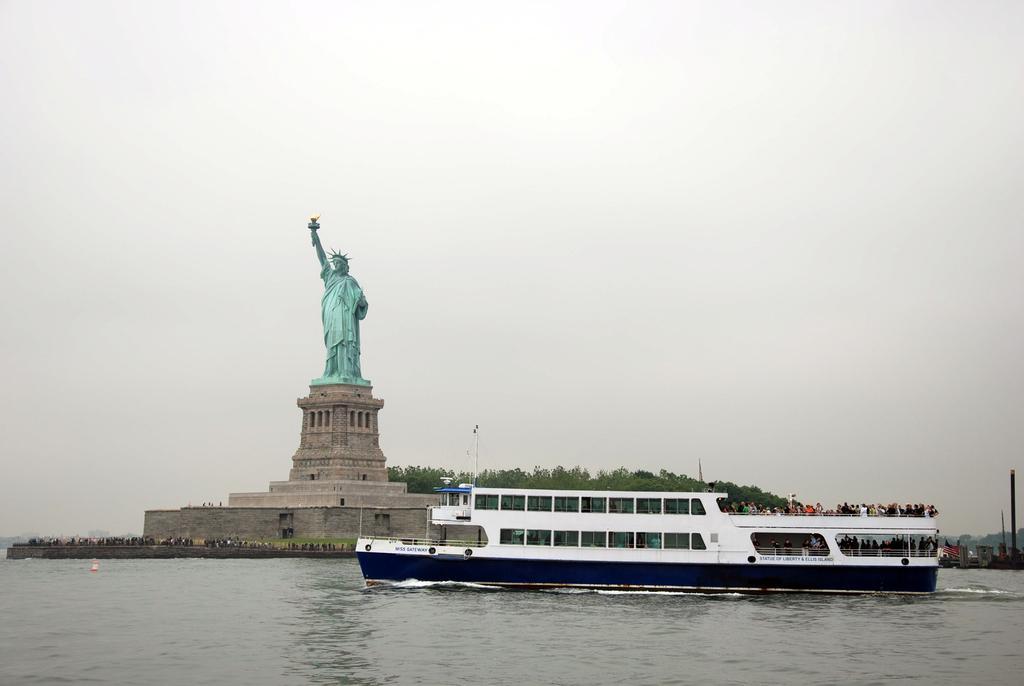Describe this image in one or two sentences. This picture is clicked outside. In the center we can see a ship and some objects in the water body. In the background we can see the sky, trees, metal rods and some other objects. On the left we can see the statue of liberty standing and holding a torch and we can see the group of persons and some other objects. 